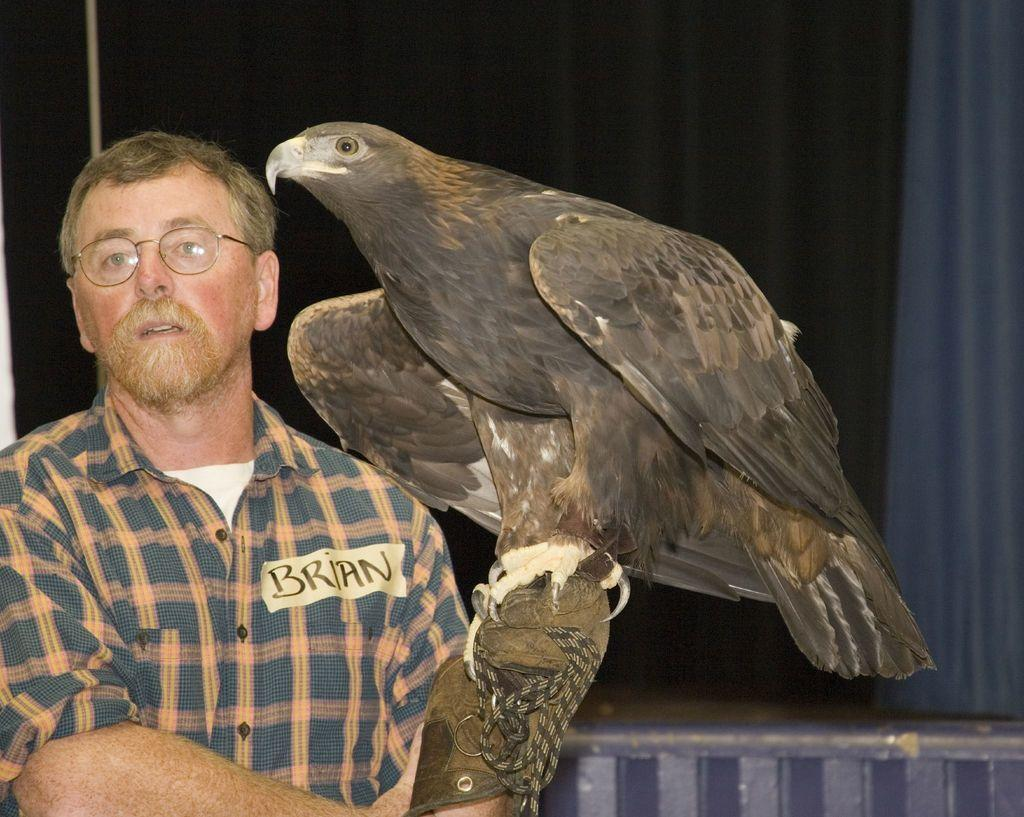What animal is present in the image? There is an eagle in the image. What is the eagle doing in the image? The eagle is sitting on the hand of a person. What type of pen is the eagle holding in its beak in the image? There is no pen present in the image; the eagle is sitting on the hand of a person. 